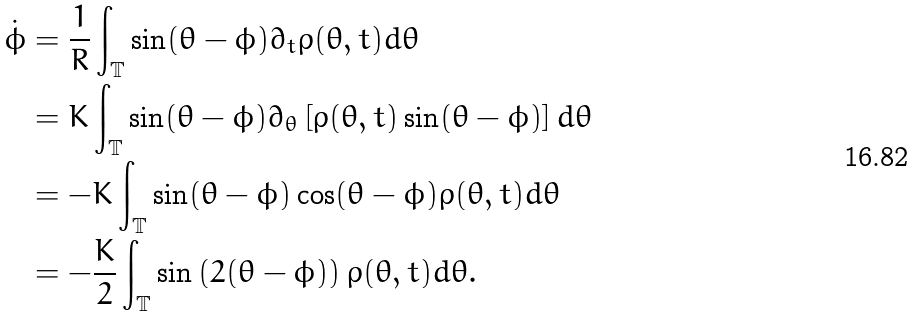Convert formula to latex. <formula><loc_0><loc_0><loc_500><loc_500>\dot { \phi } & = \frac { 1 } { R } \int _ { \mathbb { T } } \sin ( \theta - \phi ) \partial _ { t } \rho ( \theta , t ) d \theta \\ & = K \int _ { \mathbb { T } } \sin ( \theta - \phi ) \partial _ { \theta } \left [ \rho ( \theta , t ) \sin ( \theta - \phi ) \right ] d \theta \\ & = - K \int _ { \mathbb { T } } \sin ( \theta - \phi ) \cos ( \theta - \phi ) \rho ( \theta , t ) d \theta \\ & = - \frac { K } { 2 } \int _ { \mathbb { T } } \sin \left ( 2 ( \theta - \phi ) \right ) \rho ( \theta , t ) d \theta .</formula> 